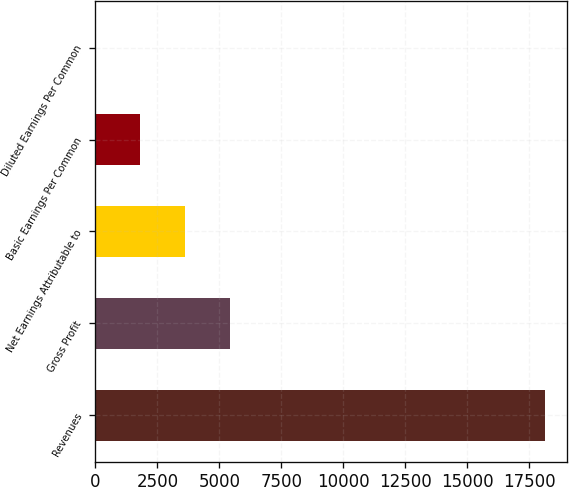Convert chart. <chart><loc_0><loc_0><loc_500><loc_500><bar_chart><fcel>Revenues<fcel>Gross Profit<fcel>Net Earnings Attributable to<fcel>Basic Earnings Per Common<fcel>Diluted Earnings Per Common<nl><fcel>18117<fcel>5435.91<fcel>3624.32<fcel>1812.73<fcel>1.14<nl></chart> 